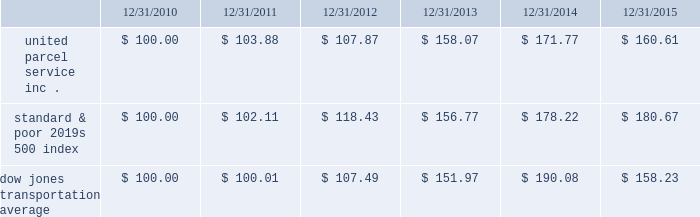Shareowner return performance graph the following performance graph and related information shall not be deemed 201csoliciting material 201d or to be 201cfiled 201d with the sec , nor shall such information be incorporated by reference into any future filing under the securities act of 1933 or securities exchange act of 1934 , each as amended , except to the extent that the company specifically incorporates such information by reference into such filing .
The following graph shows a five year comparison of cumulative total shareowners 2019 returns for our class b common stock , the standard & poor 2019s 500 index , and the dow jones transportation average .
The comparison of the total cumulative return on investment , which is the change in the quarterly stock price plus reinvested dividends for each of the quarterly periods , assumes that $ 100 was invested on december 31 , 2010 in the standard & poor 2019s 500 index , the dow jones transportation average , and our class b common stock. .

What was the percentage total cumulative return on investment for united parcel service inc . for the five year period ending 12/31/2015? 
Computations: ((160.61 - 100) / 100)
Answer: 0.6061. 